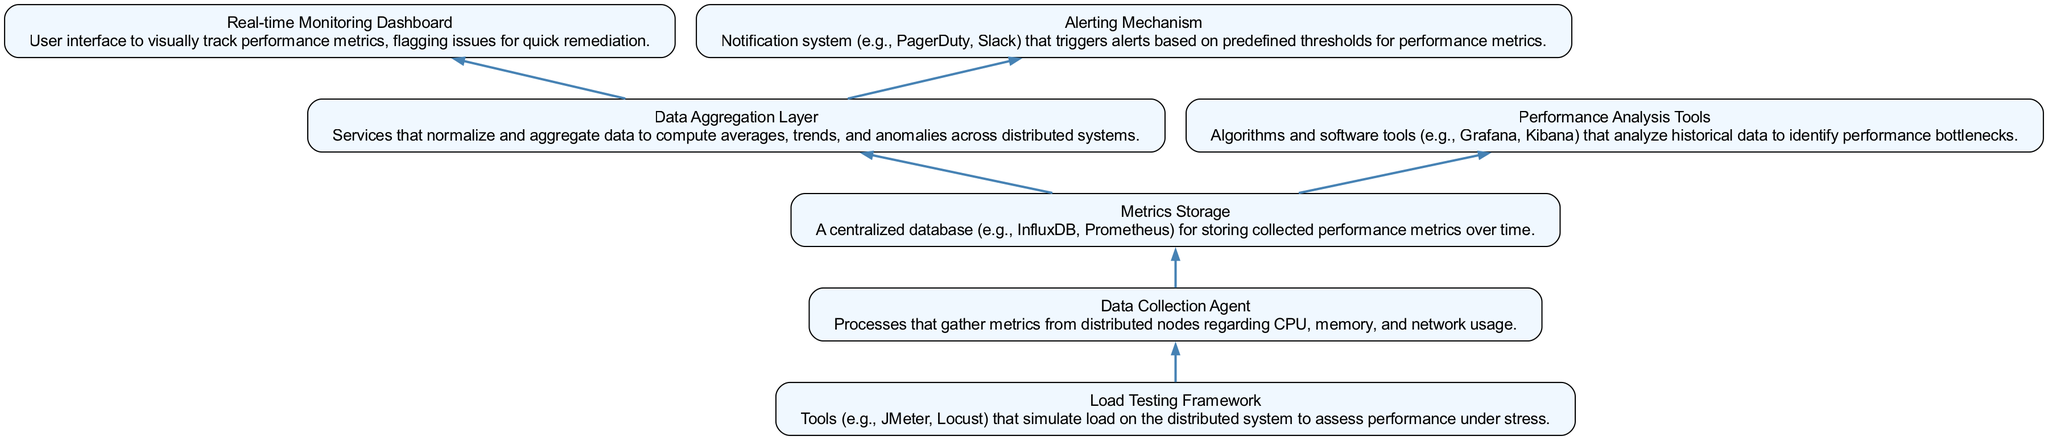What is the starting point of the flow chart? The starting point of the flow chart is the "Data Collection Agent," which represents the initial processes that gather metrics from distributed nodes.
Answer: Data Collection Agent How many nodes are present in the diagram? There are a total of seven nodes represented in the diagram, including all the components involved in performance monitoring and analysis.
Answer: Seven Which node is responsible for storing collected performance metrics? The "Metrics Storage" node is designated for storing collected performance metrics over time.
Answer: Metrics Storage What does the "Data Aggregation Layer" feed into? The "Data Aggregation Layer" feeds into the "Real-time Monitoring Dashboard" and the "Alerting Mechanism," providing a means for visual tracking and notifications.
Answer: Real-time Monitoring Dashboard and Alerting Mechanism Which component simulates load on the distributed system? The "Load Testing Framework" is the component that simulates load on the distributed system to assess performance under stress.
Answer: Load Testing Framework What is the relationship between "Metrics Storage" and "Performance Analysis Tools"? The "Metrics Storage" node provides data to the "Performance Analysis Tools" for analyzing historical data to identify performance bottlenecks.
Answer: Metrics Storage provides data to Performance Analysis Tools How does the "Load Testing Framework" relate to the "Data Collection Agent"? The "Load Testing Framework" serves as an input mechanism for the "Data Collection Agent," simulating conditions under which performance metrics are gathered.
Answer: Load Testing Framework feeds into Data Collection Agent What type of metrics does the "Data Collection Agent" monitor? The "Data Collection Agent" monitors metrics such as CPU, memory, and network usage from distributed nodes.
Answer: CPU, memory, and network usage 